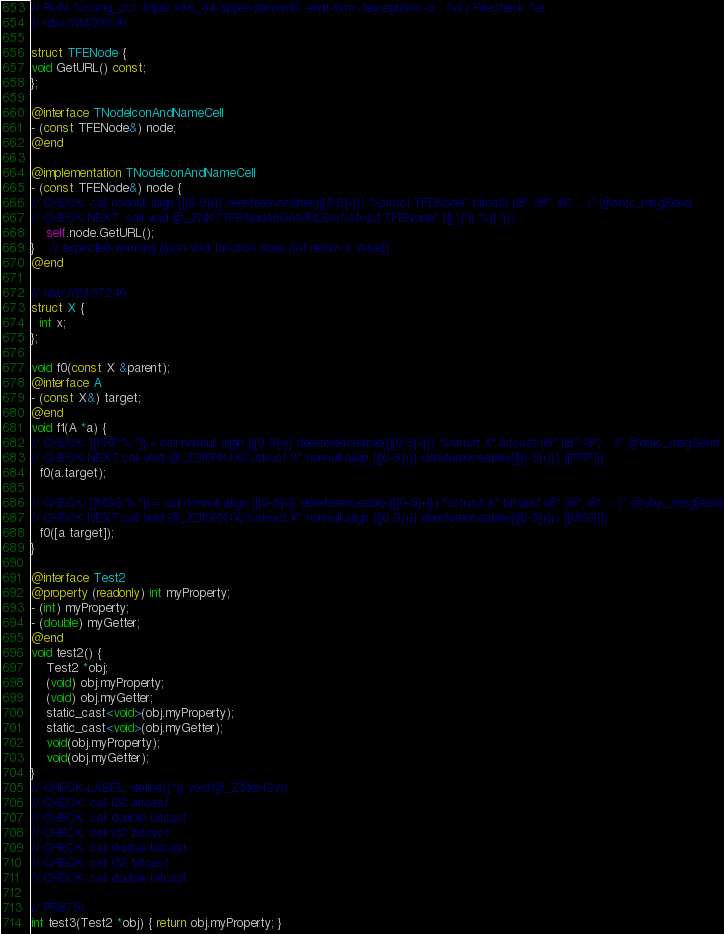<code> <loc_0><loc_0><loc_500><loc_500><_ObjectiveC_>// RUN: %clang_cc1 -triple x86_64-apple-darwin10 -emit-llvm -fexceptions -o - %s | FileCheck %s
// rdar://8409336

struct TFENode {
void GetURL() const;
};

@interface TNodeIconAndNameCell
- (const TFENode&) node;
@end

@implementation TNodeIconAndNameCell     
- (const TFENode&) node {
// CHECK: call nonnull align {{[0-9]+}} dereferenceable({{[0-9]+}}) %struct.TFENode* bitcast (i8* (i8*, i8*, ...)* @objc_msgSend
// CHECK-NEXT: call void @_ZNK7TFENode6GetURLEv(%struct.TFENode* {{[^,]*}} %{{.*}})
	self.node.GetURL();
}	// expected-warning {{non-void function does not return a value}}
@end

// rdar://8437240
struct X {
  int x;
};

void f0(const X &parent);
@interface A
- (const X&) target;
@end
void f1(A *a) {
// CHECK: [[PRP:%.*]] = call nonnull align {{[0-9]+}} dereferenceable({{[0-9]+}}) %struct.X* bitcast (i8* (i8*, i8*, ...)* @objc_msgSend
// CHECK-NEXT:call void @_Z2f0RK1X(%struct.X* nonnull align {{[0-9]+}} dereferenceable({{[0-9]+}}) [[PRP]])
  f0(a.target);

// CHECK: [[MSG:%.*]] = call nonnull align {{[0-9]+}} dereferenceable({{[0-9]+}}) %struct.X* bitcast (i8* (i8*, i8*, ...)* @objc_msgSend
// CHECK-NEXT:call void @_Z2f0RK1X(%struct.X* nonnull align {{[0-9]+}} dereferenceable({{[0-9]+}}) [[MSG]])
  f0([a target]);
}

@interface Test2
@property (readonly) int myProperty;
- (int) myProperty;
- (double) myGetter;
@end
void test2() {
    Test2 *obj;
    (void) obj.myProperty; 
    (void) obj.myGetter; 
    static_cast<void>(obj.myProperty);
    static_cast<void>(obj.myGetter);
    void(obj.myProperty);
    void(obj.myGetter);
}
// CHECK-LABEL: define{{.*}} void @_Z5test2v()
// CHECK: call i32 bitcast
// CHECK: call double bitcast
// CHECK: call i32 bitcast
// CHECK: call double bitcast
// CHECK: call i32 bitcast
// CHECK: call double bitcast

// PR8751
int test3(Test2 *obj) { return obj.myProperty; }
</code> 